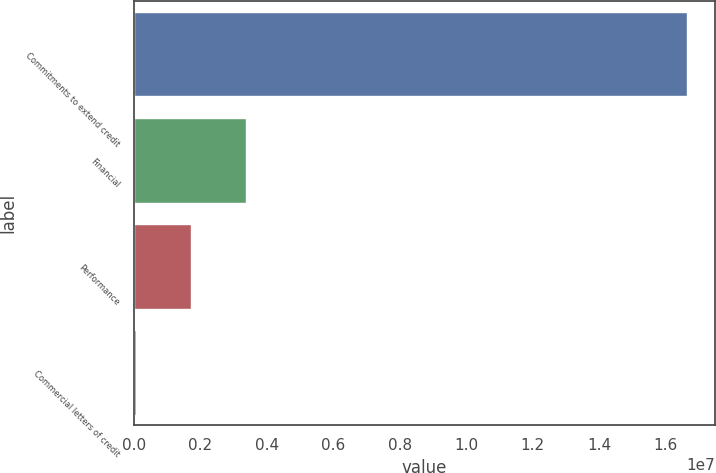<chart> <loc_0><loc_0><loc_500><loc_500><bar_chart><fcel>Commitments to extend credit<fcel>Financial<fcel>Performance<fcel>Commercial letters of credit<nl><fcel>1.66481e+07<fcel>3.36909e+06<fcel>1.70922e+06<fcel>49346<nl></chart> 